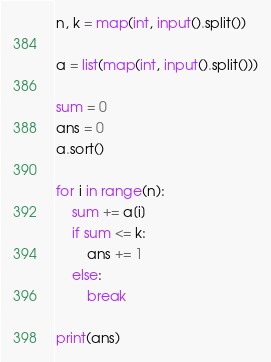Convert code to text. <code><loc_0><loc_0><loc_500><loc_500><_Python_>n, k = map(int, input().split())

a = list(map(int, input().split()))

sum = 0
ans = 0
a.sort()

for i in range(n):
    sum += a[i]
    if sum <= k:
        ans += 1
    else:
        break

print(ans)

</code> 